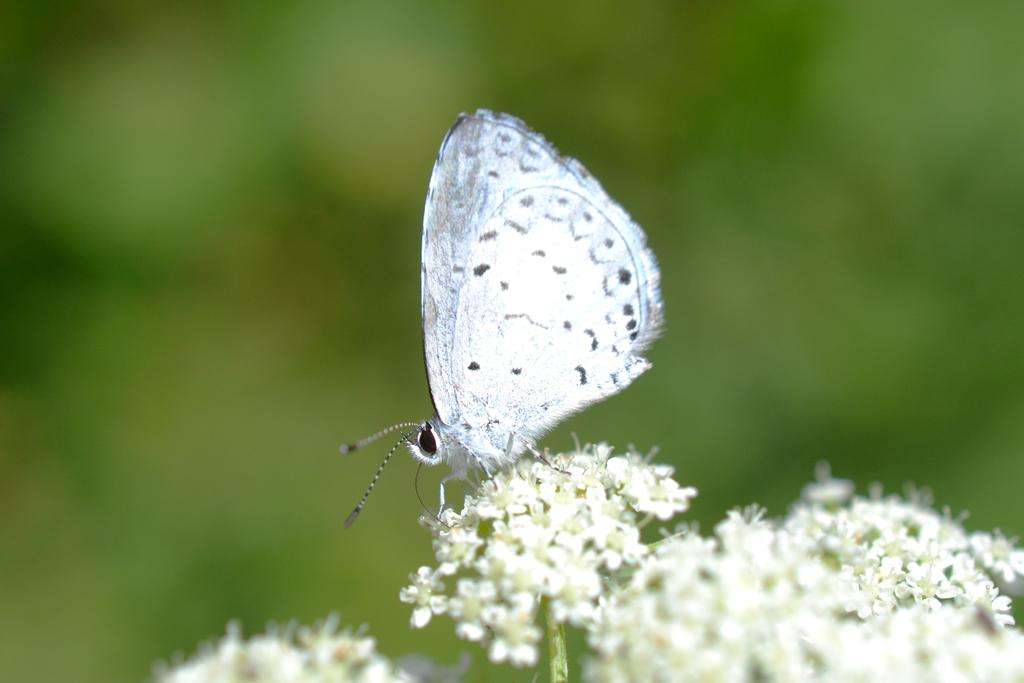What type of flowers are present in the image? There are white color flowers in the image. Is there any other living creature visible in the image besides the flowers? Yes, there is a white butterfly on the flowers. What can be observed about the background of the image? The background of the image is green and blurred. What songs can be heard playing in the background of the image? There is no audio or sound present in the image, so it is not possible to determine what songs might be heard. 